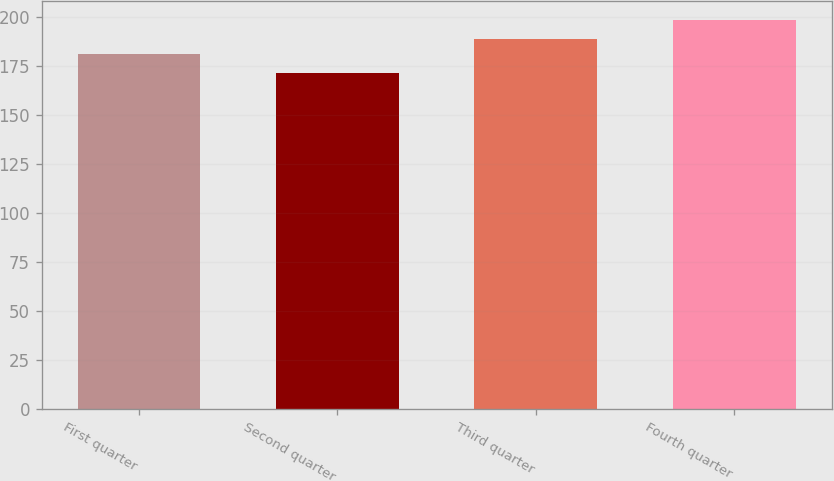Convert chart to OTSL. <chart><loc_0><loc_0><loc_500><loc_500><bar_chart><fcel>First quarter<fcel>Second quarter<fcel>Third quarter<fcel>Fourth quarter<nl><fcel>181.13<fcel>171.08<fcel>188.58<fcel>198.06<nl></chart> 